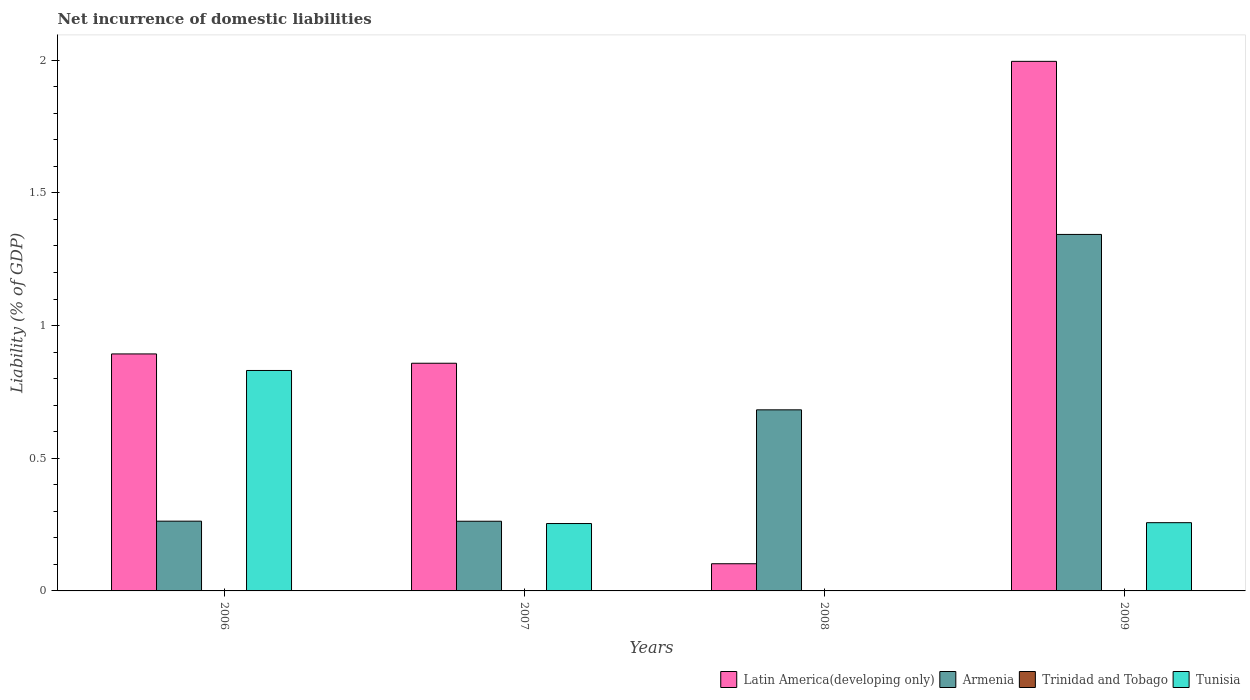How many bars are there on the 2nd tick from the left?
Give a very brief answer. 3. What is the label of the 2nd group of bars from the left?
Ensure brevity in your answer.  2007. In how many cases, is the number of bars for a given year not equal to the number of legend labels?
Your answer should be very brief. 4. What is the net incurrence of domestic liabilities in Trinidad and Tobago in 2007?
Keep it short and to the point. 0. Across all years, what is the maximum net incurrence of domestic liabilities in Armenia?
Ensure brevity in your answer.  1.34. Across all years, what is the minimum net incurrence of domestic liabilities in Latin America(developing only)?
Keep it short and to the point. 0.1. What is the total net incurrence of domestic liabilities in Trinidad and Tobago in the graph?
Your answer should be compact. 0. What is the difference between the net incurrence of domestic liabilities in Latin America(developing only) in 2007 and that in 2009?
Your response must be concise. -1.14. What is the difference between the net incurrence of domestic liabilities in Latin America(developing only) in 2009 and the net incurrence of domestic liabilities in Armenia in 2006?
Give a very brief answer. 1.73. What is the average net incurrence of domestic liabilities in Latin America(developing only) per year?
Offer a very short reply. 0.96. In the year 2007, what is the difference between the net incurrence of domestic liabilities in Tunisia and net incurrence of domestic liabilities in Armenia?
Offer a terse response. -0.01. What is the ratio of the net incurrence of domestic liabilities in Armenia in 2006 to that in 2008?
Offer a terse response. 0.39. Is the net incurrence of domestic liabilities in Armenia in 2007 less than that in 2008?
Your answer should be very brief. Yes. What is the difference between the highest and the second highest net incurrence of domestic liabilities in Armenia?
Your response must be concise. 0.66. What is the difference between the highest and the lowest net incurrence of domestic liabilities in Tunisia?
Ensure brevity in your answer.  0.83. Is the sum of the net incurrence of domestic liabilities in Armenia in 2006 and 2008 greater than the maximum net incurrence of domestic liabilities in Latin America(developing only) across all years?
Your answer should be very brief. No. Is it the case that in every year, the sum of the net incurrence of domestic liabilities in Armenia and net incurrence of domestic liabilities in Trinidad and Tobago is greater than the sum of net incurrence of domestic liabilities in Tunisia and net incurrence of domestic liabilities in Latin America(developing only)?
Provide a succinct answer. No. How many bars are there?
Make the answer very short. 11. Does the graph contain any zero values?
Your answer should be compact. Yes. Does the graph contain grids?
Provide a succinct answer. No. Where does the legend appear in the graph?
Ensure brevity in your answer.  Bottom right. How are the legend labels stacked?
Make the answer very short. Horizontal. What is the title of the graph?
Give a very brief answer. Net incurrence of domestic liabilities. Does "Small states" appear as one of the legend labels in the graph?
Provide a short and direct response. No. What is the label or title of the X-axis?
Keep it short and to the point. Years. What is the label or title of the Y-axis?
Ensure brevity in your answer.  Liability (% of GDP). What is the Liability (% of GDP) of Latin America(developing only) in 2006?
Make the answer very short. 0.89. What is the Liability (% of GDP) of Armenia in 2006?
Offer a very short reply. 0.26. What is the Liability (% of GDP) in Tunisia in 2006?
Give a very brief answer. 0.83. What is the Liability (% of GDP) in Latin America(developing only) in 2007?
Ensure brevity in your answer.  0.86. What is the Liability (% of GDP) in Armenia in 2007?
Offer a terse response. 0.26. What is the Liability (% of GDP) in Trinidad and Tobago in 2007?
Give a very brief answer. 0. What is the Liability (% of GDP) of Tunisia in 2007?
Your response must be concise. 0.25. What is the Liability (% of GDP) in Latin America(developing only) in 2008?
Keep it short and to the point. 0.1. What is the Liability (% of GDP) of Armenia in 2008?
Provide a short and direct response. 0.68. What is the Liability (% of GDP) in Trinidad and Tobago in 2008?
Make the answer very short. 0. What is the Liability (% of GDP) in Tunisia in 2008?
Offer a terse response. 0. What is the Liability (% of GDP) in Latin America(developing only) in 2009?
Offer a very short reply. 2. What is the Liability (% of GDP) of Armenia in 2009?
Offer a very short reply. 1.34. What is the Liability (% of GDP) in Tunisia in 2009?
Offer a very short reply. 0.26. Across all years, what is the maximum Liability (% of GDP) in Latin America(developing only)?
Provide a succinct answer. 2. Across all years, what is the maximum Liability (% of GDP) of Armenia?
Offer a terse response. 1.34. Across all years, what is the maximum Liability (% of GDP) of Tunisia?
Ensure brevity in your answer.  0.83. Across all years, what is the minimum Liability (% of GDP) of Latin America(developing only)?
Make the answer very short. 0.1. Across all years, what is the minimum Liability (% of GDP) of Armenia?
Provide a short and direct response. 0.26. What is the total Liability (% of GDP) in Latin America(developing only) in the graph?
Keep it short and to the point. 3.85. What is the total Liability (% of GDP) in Armenia in the graph?
Offer a very short reply. 2.55. What is the total Liability (% of GDP) of Tunisia in the graph?
Make the answer very short. 1.34. What is the difference between the Liability (% of GDP) of Latin America(developing only) in 2006 and that in 2007?
Give a very brief answer. 0.04. What is the difference between the Liability (% of GDP) of Tunisia in 2006 and that in 2007?
Offer a very short reply. 0.58. What is the difference between the Liability (% of GDP) in Latin America(developing only) in 2006 and that in 2008?
Provide a short and direct response. 0.79. What is the difference between the Liability (% of GDP) in Armenia in 2006 and that in 2008?
Give a very brief answer. -0.42. What is the difference between the Liability (% of GDP) in Latin America(developing only) in 2006 and that in 2009?
Your answer should be compact. -1.1. What is the difference between the Liability (% of GDP) of Armenia in 2006 and that in 2009?
Offer a terse response. -1.08. What is the difference between the Liability (% of GDP) in Tunisia in 2006 and that in 2009?
Make the answer very short. 0.57. What is the difference between the Liability (% of GDP) in Latin America(developing only) in 2007 and that in 2008?
Offer a very short reply. 0.76. What is the difference between the Liability (% of GDP) in Armenia in 2007 and that in 2008?
Provide a succinct answer. -0.42. What is the difference between the Liability (% of GDP) in Latin America(developing only) in 2007 and that in 2009?
Make the answer very short. -1.14. What is the difference between the Liability (% of GDP) in Armenia in 2007 and that in 2009?
Your answer should be very brief. -1.08. What is the difference between the Liability (% of GDP) in Tunisia in 2007 and that in 2009?
Provide a short and direct response. -0. What is the difference between the Liability (% of GDP) of Latin America(developing only) in 2008 and that in 2009?
Your answer should be very brief. -1.89. What is the difference between the Liability (% of GDP) in Armenia in 2008 and that in 2009?
Provide a succinct answer. -0.66. What is the difference between the Liability (% of GDP) in Latin America(developing only) in 2006 and the Liability (% of GDP) in Armenia in 2007?
Provide a succinct answer. 0.63. What is the difference between the Liability (% of GDP) in Latin America(developing only) in 2006 and the Liability (% of GDP) in Tunisia in 2007?
Offer a terse response. 0.64. What is the difference between the Liability (% of GDP) in Armenia in 2006 and the Liability (% of GDP) in Tunisia in 2007?
Offer a very short reply. 0.01. What is the difference between the Liability (% of GDP) in Latin America(developing only) in 2006 and the Liability (% of GDP) in Armenia in 2008?
Offer a terse response. 0.21. What is the difference between the Liability (% of GDP) of Latin America(developing only) in 2006 and the Liability (% of GDP) of Armenia in 2009?
Ensure brevity in your answer.  -0.45. What is the difference between the Liability (% of GDP) in Latin America(developing only) in 2006 and the Liability (% of GDP) in Tunisia in 2009?
Ensure brevity in your answer.  0.64. What is the difference between the Liability (% of GDP) in Armenia in 2006 and the Liability (% of GDP) in Tunisia in 2009?
Your answer should be compact. 0.01. What is the difference between the Liability (% of GDP) in Latin America(developing only) in 2007 and the Liability (% of GDP) in Armenia in 2008?
Offer a terse response. 0.18. What is the difference between the Liability (% of GDP) in Latin America(developing only) in 2007 and the Liability (% of GDP) in Armenia in 2009?
Your answer should be very brief. -0.49. What is the difference between the Liability (% of GDP) in Latin America(developing only) in 2007 and the Liability (% of GDP) in Tunisia in 2009?
Your answer should be very brief. 0.6. What is the difference between the Liability (% of GDP) in Armenia in 2007 and the Liability (% of GDP) in Tunisia in 2009?
Your answer should be compact. 0.01. What is the difference between the Liability (% of GDP) in Latin America(developing only) in 2008 and the Liability (% of GDP) in Armenia in 2009?
Give a very brief answer. -1.24. What is the difference between the Liability (% of GDP) of Latin America(developing only) in 2008 and the Liability (% of GDP) of Tunisia in 2009?
Your answer should be compact. -0.15. What is the difference between the Liability (% of GDP) of Armenia in 2008 and the Liability (% of GDP) of Tunisia in 2009?
Provide a short and direct response. 0.43. What is the average Liability (% of GDP) of Latin America(developing only) per year?
Ensure brevity in your answer.  0.96. What is the average Liability (% of GDP) of Armenia per year?
Your response must be concise. 0.64. What is the average Liability (% of GDP) in Tunisia per year?
Your response must be concise. 0.34. In the year 2006, what is the difference between the Liability (% of GDP) in Latin America(developing only) and Liability (% of GDP) in Armenia?
Keep it short and to the point. 0.63. In the year 2006, what is the difference between the Liability (% of GDP) of Latin America(developing only) and Liability (% of GDP) of Tunisia?
Make the answer very short. 0.06. In the year 2006, what is the difference between the Liability (% of GDP) in Armenia and Liability (% of GDP) in Tunisia?
Provide a short and direct response. -0.57. In the year 2007, what is the difference between the Liability (% of GDP) of Latin America(developing only) and Liability (% of GDP) of Armenia?
Provide a succinct answer. 0.6. In the year 2007, what is the difference between the Liability (% of GDP) of Latin America(developing only) and Liability (% of GDP) of Tunisia?
Offer a very short reply. 0.6. In the year 2007, what is the difference between the Liability (% of GDP) in Armenia and Liability (% of GDP) in Tunisia?
Keep it short and to the point. 0.01. In the year 2008, what is the difference between the Liability (% of GDP) in Latin America(developing only) and Liability (% of GDP) in Armenia?
Provide a short and direct response. -0.58. In the year 2009, what is the difference between the Liability (% of GDP) of Latin America(developing only) and Liability (% of GDP) of Armenia?
Provide a short and direct response. 0.65. In the year 2009, what is the difference between the Liability (% of GDP) of Latin America(developing only) and Liability (% of GDP) of Tunisia?
Your response must be concise. 1.74. In the year 2009, what is the difference between the Liability (% of GDP) of Armenia and Liability (% of GDP) of Tunisia?
Your response must be concise. 1.09. What is the ratio of the Liability (% of GDP) in Latin America(developing only) in 2006 to that in 2007?
Ensure brevity in your answer.  1.04. What is the ratio of the Liability (% of GDP) of Tunisia in 2006 to that in 2007?
Your answer should be very brief. 3.27. What is the ratio of the Liability (% of GDP) of Latin America(developing only) in 2006 to that in 2008?
Provide a succinct answer. 8.72. What is the ratio of the Liability (% of GDP) of Armenia in 2006 to that in 2008?
Offer a very short reply. 0.39. What is the ratio of the Liability (% of GDP) of Latin America(developing only) in 2006 to that in 2009?
Make the answer very short. 0.45. What is the ratio of the Liability (% of GDP) in Armenia in 2006 to that in 2009?
Your response must be concise. 0.2. What is the ratio of the Liability (% of GDP) in Tunisia in 2006 to that in 2009?
Offer a very short reply. 3.23. What is the ratio of the Liability (% of GDP) of Latin America(developing only) in 2007 to that in 2008?
Your answer should be very brief. 8.38. What is the ratio of the Liability (% of GDP) of Armenia in 2007 to that in 2008?
Offer a terse response. 0.38. What is the ratio of the Liability (% of GDP) of Latin America(developing only) in 2007 to that in 2009?
Give a very brief answer. 0.43. What is the ratio of the Liability (% of GDP) of Armenia in 2007 to that in 2009?
Provide a short and direct response. 0.2. What is the ratio of the Liability (% of GDP) of Tunisia in 2007 to that in 2009?
Give a very brief answer. 0.99. What is the ratio of the Liability (% of GDP) in Latin America(developing only) in 2008 to that in 2009?
Ensure brevity in your answer.  0.05. What is the ratio of the Liability (% of GDP) in Armenia in 2008 to that in 2009?
Your answer should be very brief. 0.51. What is the difference between the highest and the second highest Liability (% of GDP) in Latin America(developing only)?
Make the answer very short. 1.1. What is the difference between the highest and the second highest Liability (% of GDP) in Armenia?
Give a very brief answer. 0.66. What is the difference between the highest and the second highest Liability (% of GDP) in Tunisia?
Your answer should be very brief. 0.57. What is the difference between the highest and the lowest Liability (% of GDP) in Latin America(developing only)?
Offer a terse response. 1.89. What is the difference between the highest and the lowest Liability (% of GDP) of Armenia?
Make the answer very short. 1.08. What is the difference between the highest and the lowest Liability (% of GDP) in Tunisia?
Your answer should be very brief. 0.83. 